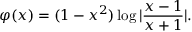Convert formula to latex. <formula><loc_0><loc_0><loc_500><loc_500>\varphi ( x ) = ( 1 - x ^ { 2 } ) \log | \frac { x - 1 } { x + 1 } | .</formula> 